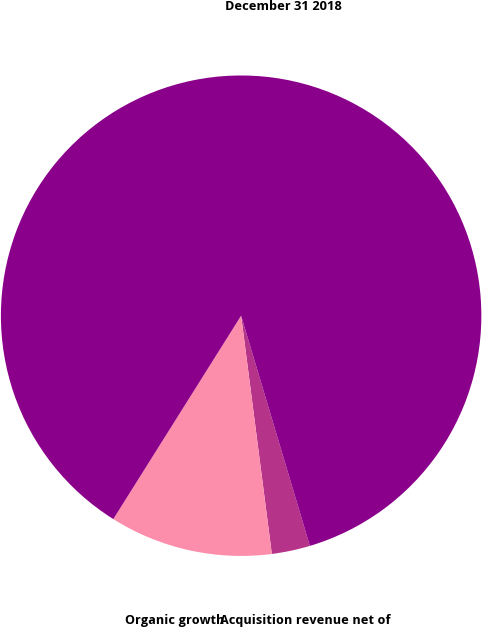Convert chart. <chart><loc_0><loc_0><loc_500><loc_500><pie_chart><fcel>Acquisition revenue net of<fcel>Organic growth<fcel>December 31 2018<nl><fcel>2.58%<fcel>10.97%<fcel>86.45%<nl></chart> 